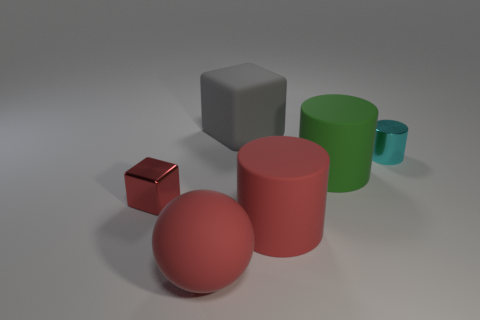Which objects are in the foreground and which are in the background? In the foreground of the image, there is a red large sphere along with a smaller red sphere, as well as a reflective small block and a pink cylinder. In the middle ground is a green mug-like object, and in the background, standing alone, is a grey, neutral-colored large block. 